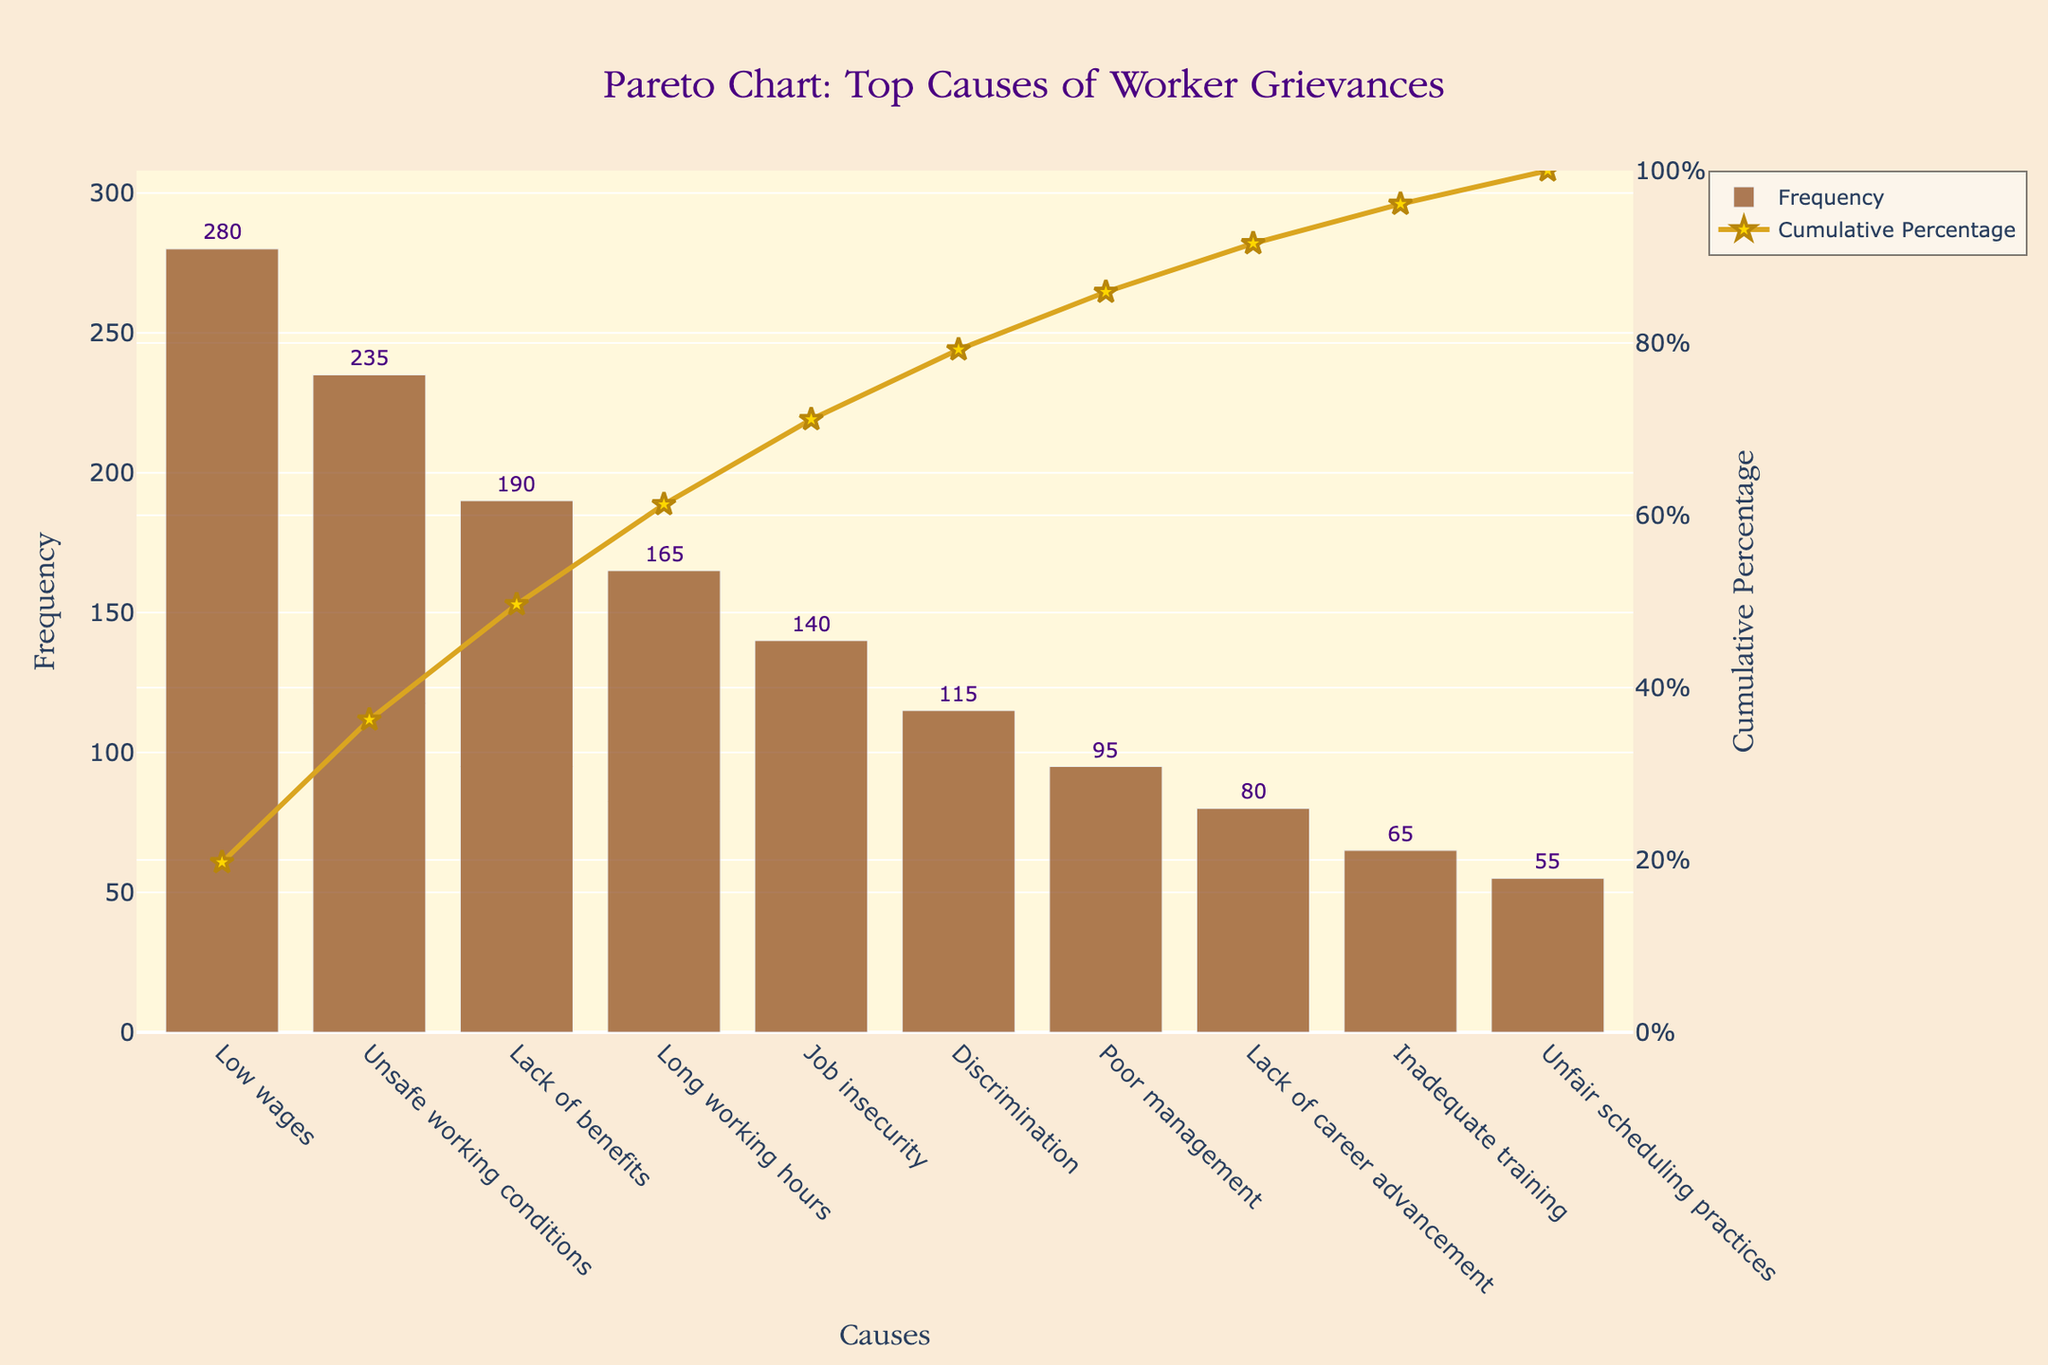What is the title of the figure? The title can be found at the top of the figure. It reads "Pareto Chart: Top Causes of Worker Grievances."
Answer: Pareto Chart: Top Causes of Worker Grievances Which cause has the highest frequency of grievances? The highest bar in the chart represents the cause with the highest frequency. It is labeled "Low wages" with a frequency of 280.
Answer: Low wages What is the cumulative percentage for "Unsafe working conditions"? On the line chart, locate the point corresponding to "Unsafe working conditions" and read the cumulative percentage value on the right y-axis. It is around 41.88%.
Answer: 41.88% How many causes have a frequency below 100? Count the bars that have a y-value (frequency) less than 100. These are "Poor management," "Lack of career advancement," "Inadequate training," and "Unfair scheduling practices," which make a total of 4.
Answer: 4 What is the difference in frequency between "Low wages" and "Discrimination"? Look at the frequencies given above the bars for "Low wages" (280) and "Discrimination" (115), then subtract the smaller from the larger: 280 - 115 = 165.
Answer: 165 What percentage of grievances is represented by "Low wages" and "Unsafe working conditions" combined? Add their frequencies (280 for "Low wages" and 235 for "Unsafe working conditions"), find their sum, and divide by the total frequency of all causes. Multiply by 100 to convert to a percentage: (280 + 235) / 1420 * 100 = 36.27%.
Answer: 36.27% Which cause has a lower frequency, "Job insecurity" or "Lack of benefits"? Compare the heights of the bars or the values listed above the bars for these causes. "Job insecurity" has 140, and "Lack of benefits" has 190, making "Job insecurity" the lower one.
Answer: Job insecurity What cumulative percentage does "Long working hours" contribute to? Locate the point on the line chart corresponding to "Long working hours" and read the value on the right y-axis. The cumulative percentage is approximately 62.61%.
Answer: 62.61% Which causes together contribute to more than 50% of the cumulative percentage? Follow the line chart to see at which points the cumulative percentage exceeds 50%. "Low wages," "Unsafe working conditions," and "Lack of benefits" together surpass this threshold, as "Lack of benefits" alone brings it to over 50%.
Answer: Low wages, Unsafe working conditions, Lack of benefits How does the frequency of "Inadequate training" compare to "Unfair scheduling practices"? Compare the heights of the bars or the values listed above the bars. "Inadequate training" has a frequency of 65, while "Unfair scheduling practices" has a frequency of 55. Thus, "Inadequate training" has a higher frequency.
Answer: Inadequate training 